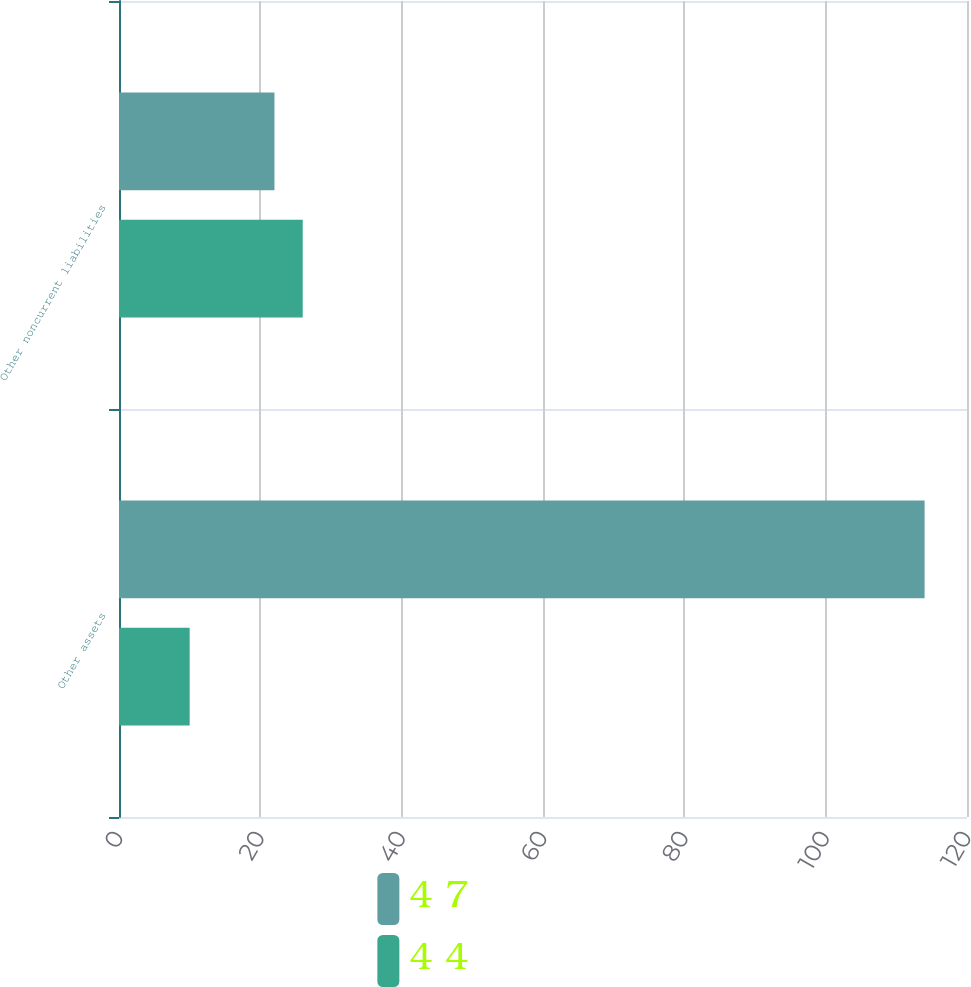Convert chart. <chart><loc_0><loc_0><loc_500><loc_500><stacked_bar_chart><ecel><fcel>Other assets<fcel>Other noncurrent liabilities<nl><fcel>4 7<fcel>114<fcel>22<nl><fcel>4 4<fcel>10<fcel>26<nl></chart> 